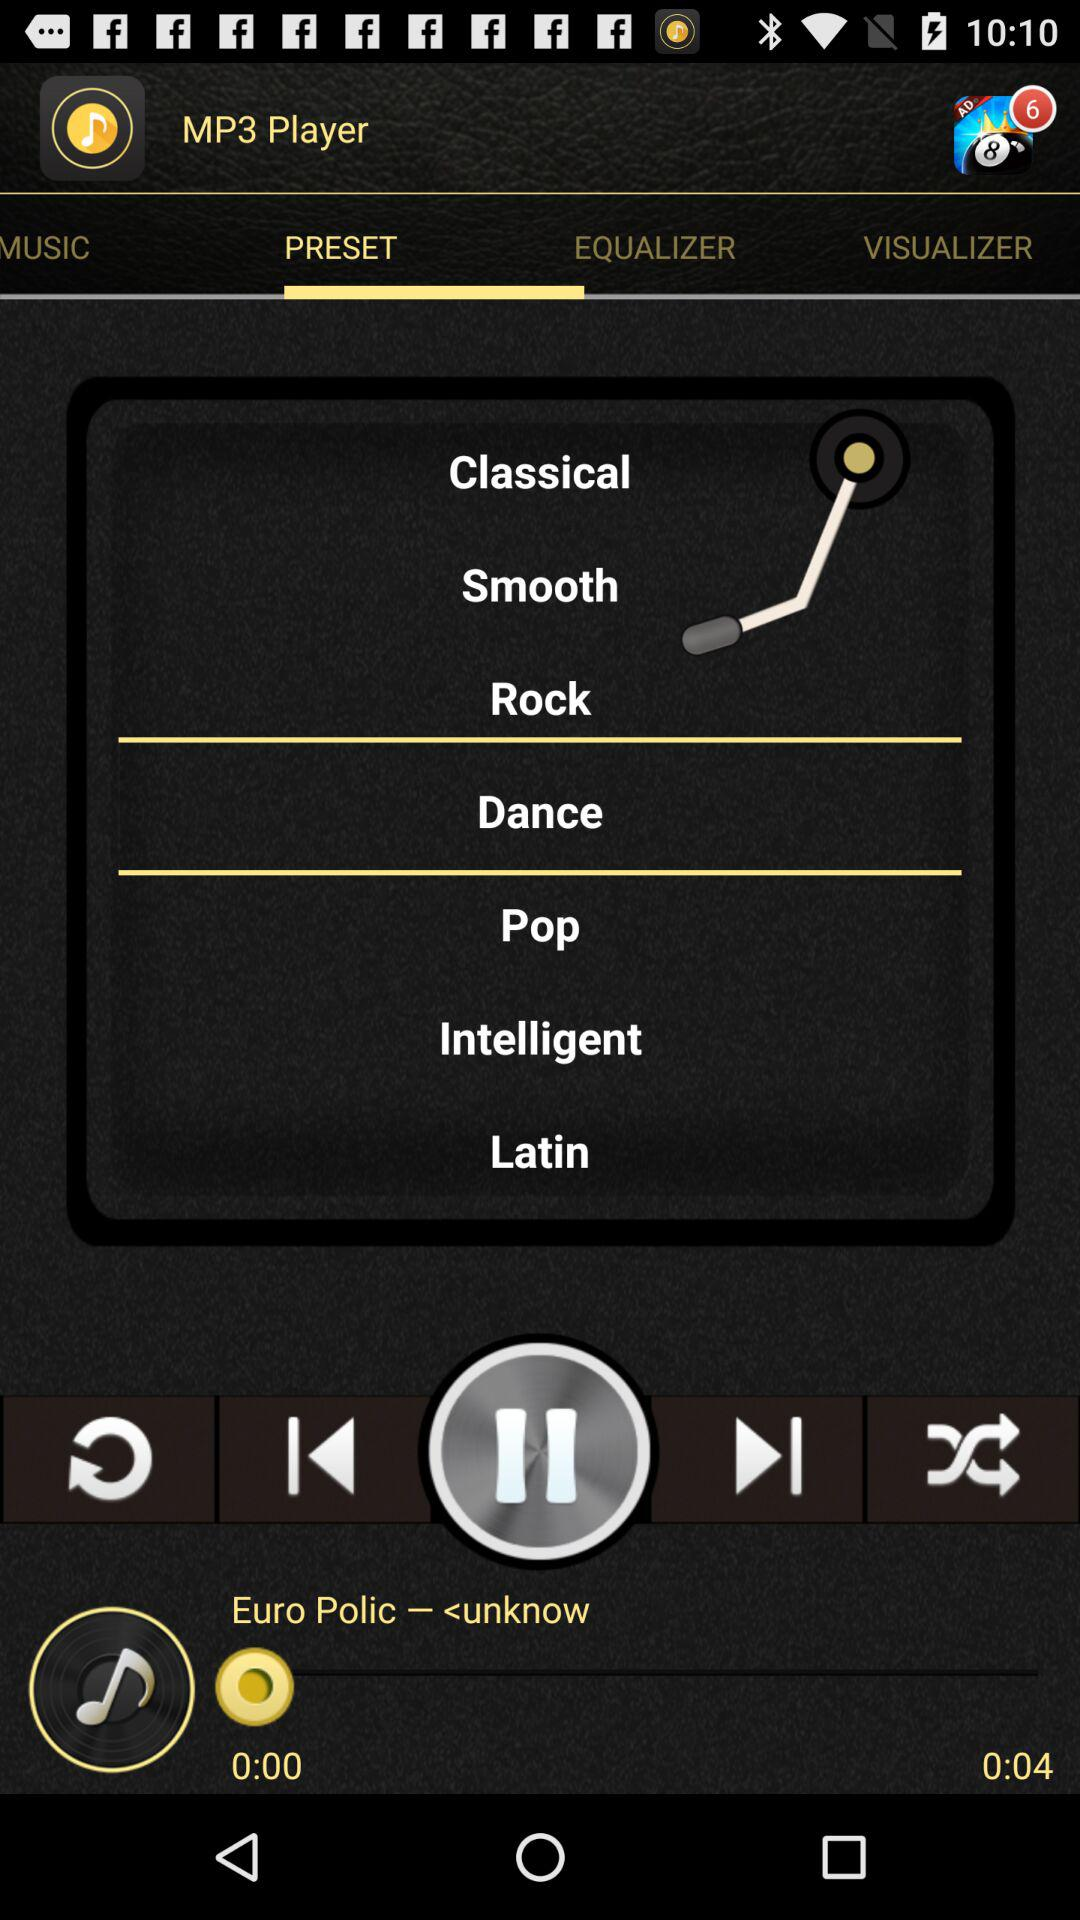What is the application name? The application name is "MP3 Player". 